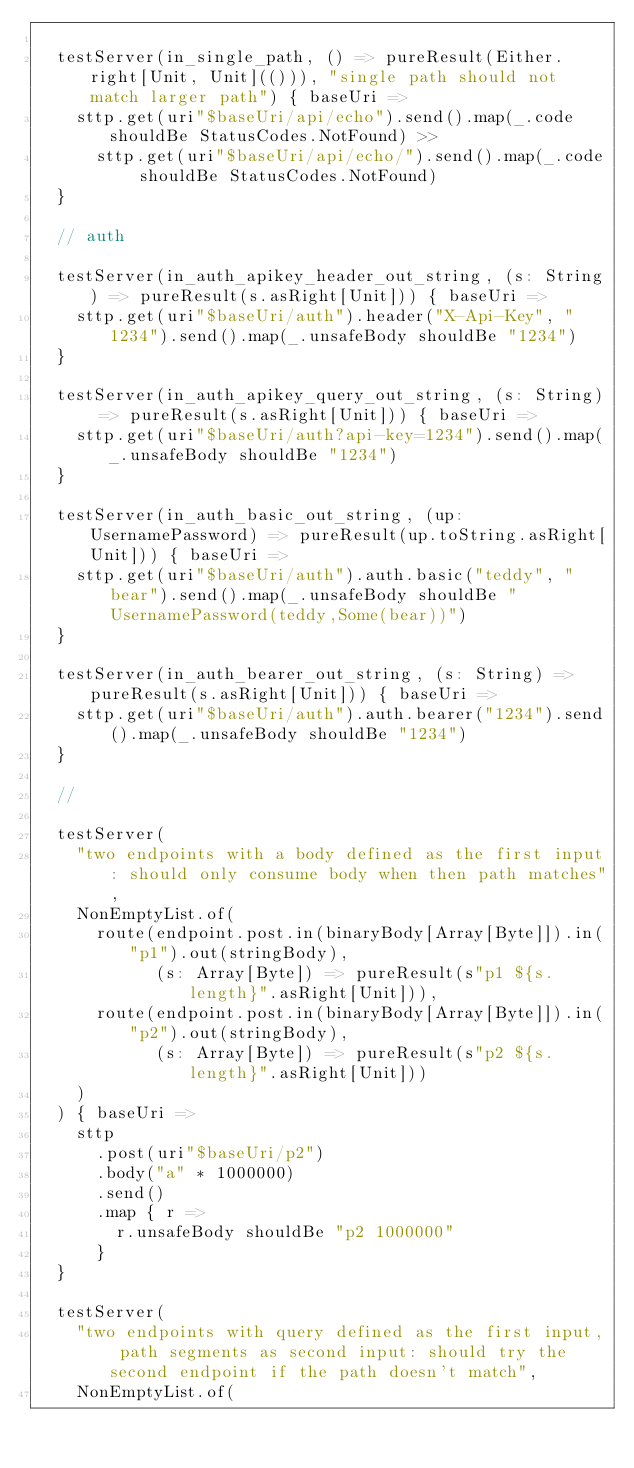Convert code to text. <code><loc_0><loc_0><loc_500><loc_500><_Scala_>
  testServer(in_single_path, () => pureResult(Either.right[Unit, Unit](())), "single path should not match larger path") { baseUri =>
    sttp.get(uri"$baseUri/api/echo").send().map(_.code shouldBe StatusCodes.NotFound) >>
      sttp.get(uri"$baseUri/api/echo/").send().map(_.code shouldBe StatusCodes.NotFound)
  }

  // auth

  testServer(in_auth_apikey_header_out_string, (s: String) => pureResult(s.asRight[Unit])) { baseUri =>
    sttp.get(uri"$baseUri/auth").header("X-Api-Key", "1234").send().map(_.unsafeBody shouldBe "1234")
  }

  testServer(in_auth_apikey_query_out_string, (s: String) => pureResult(s.asRight[Unit])) { baseUri =>
    sttp.get(uri"$baseUri/auth?api-key=1234").send().map(_.unsafeBody shouldBe "1234")
  }

  testServer(in_auth_basic_out_string, (up: UsernamePassword) => pureResult(up.toString.asRight[Unit])) { baseUri =>
    sttp.get(uri"$baseUri/auth").auth.basic("teddy", "bear").send().map(_.unsafeBody shouldBe "UsernamePassword(teddy,Some(bear))")
  }

  testServer(in_auth_bearer_out_string, (s: String) => pureResult(s.asRight[Unit])) { baseUri =>
    sttp.get(uri"$baseUri/auth").auth.bearer("1234").send().map(_.unsafeBody shouldBe "1234")
  }

  //

  testServer(
    "two endpoints with a body defined as the first input: should only consume body when then path matches",
    NonEmptyList.of(
      route(endpoint.post.in(binaryBody[Array[Byte]]).in("p1").out(stringBody),
            (s: Array[Byte]) => pureResult(s"p1 ${s.length}".asRight[Unit])),
      route(endpoint.post.in(binaryBody[Array[Byte]]).in("p2").out(stringBody),
            (s: Array[Byte]) => pureResult(s"p2 ${s.length}".asRight[Unit]))
    )
  ) { baseUri =>
    sttp
      .post(uri"$baseUri/p2")
      .body("a" * 1000000)
      .send()
      .map { r =>
        r.unsafeBody shouldBe "p2 1000000"
      }
  }

  testServer(
    "two endpoints with query defined as the first input, path segments as second input: should try the second endpoint if the path doesn't match",
    NonEmptyList.of(</code> 